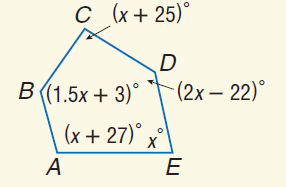Answer the mathemtical geometry problem and directly provide the correct option letter.
Question: Find m \angle B.
Choices: A: 78 B: 103 C: 105 D: 120 D 